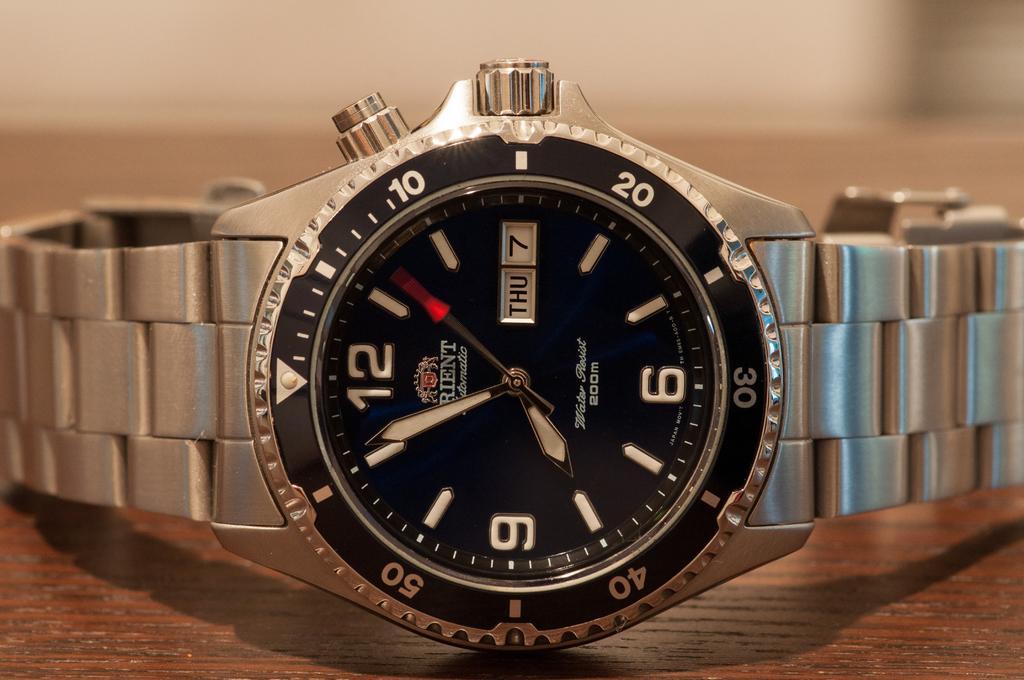Can you describe this image briefly? In the picture I can see a metal watch which is placed on a brown surface. 